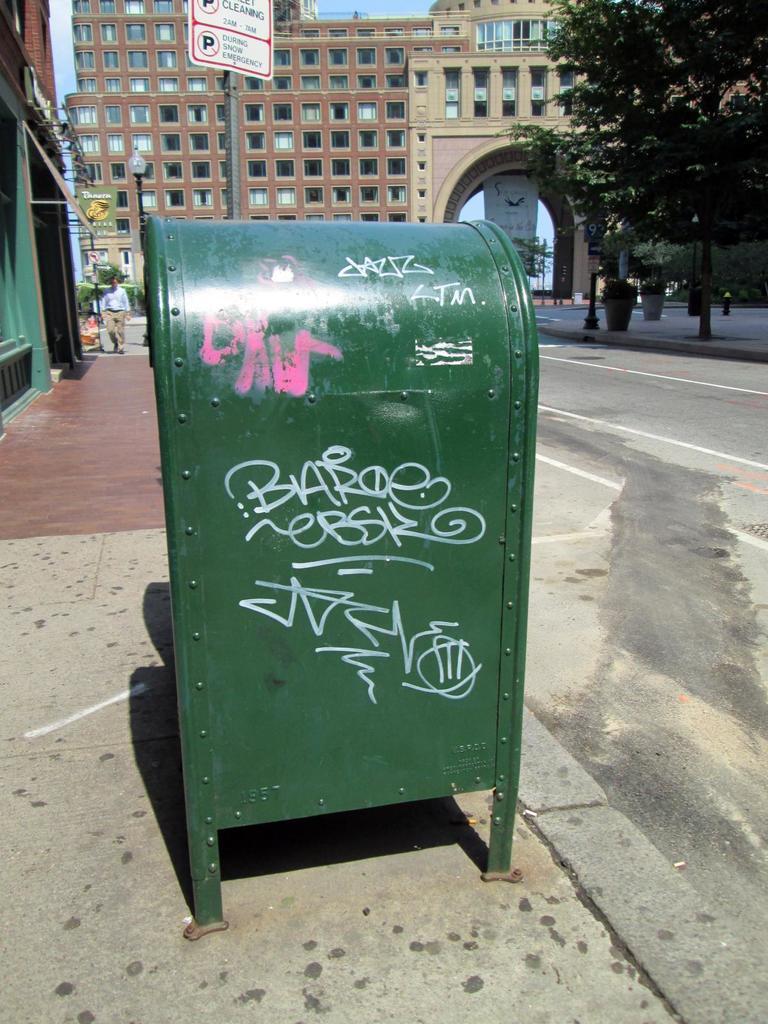What name is written in graffiti?
Your answer should be compact. Baroe. 